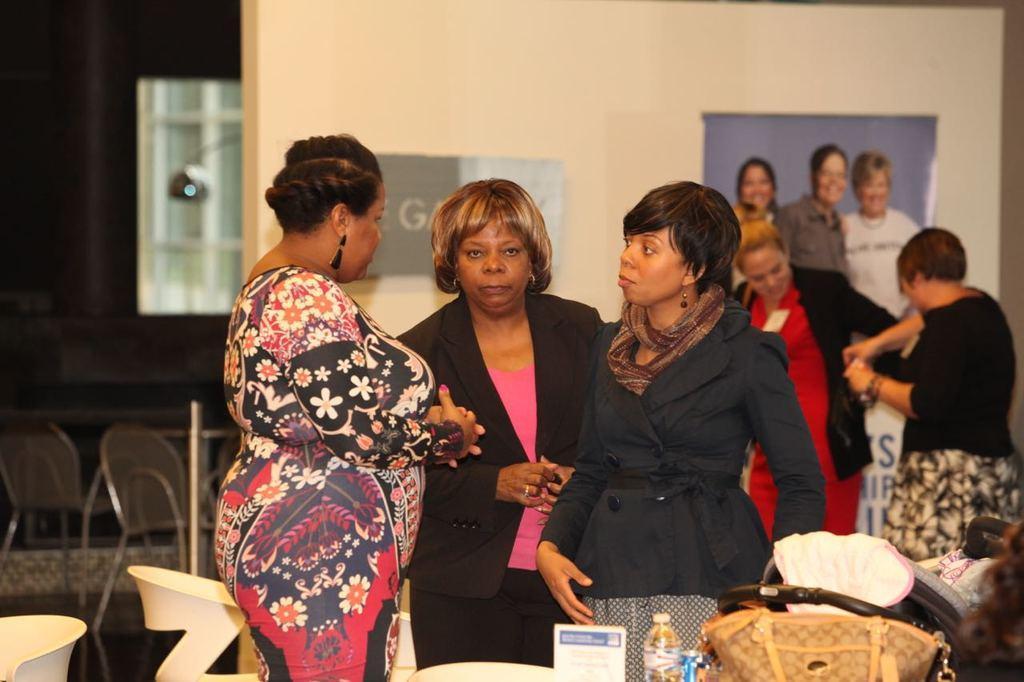Describe this image in one or two sentences. In this image in the front there are objects. In the center there are persons standing and in the background there is a board hanging on the wall and there are persons standing and smiling. On the left side there are empty chairs. 